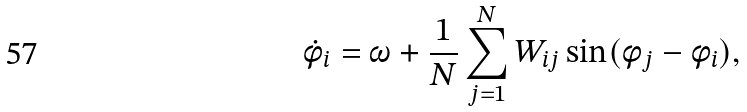Convert formula to latex. <formula><loc_0><loc_0><loc_500><loc_500>\dot { \phi } _ { i } = \omega + \frac { 1 } { N } \sum _ { j = 1 } ^ { N } W _ { i j } \sin ( \phi _ { j } - \phi _ { i } ) ,</formula> 